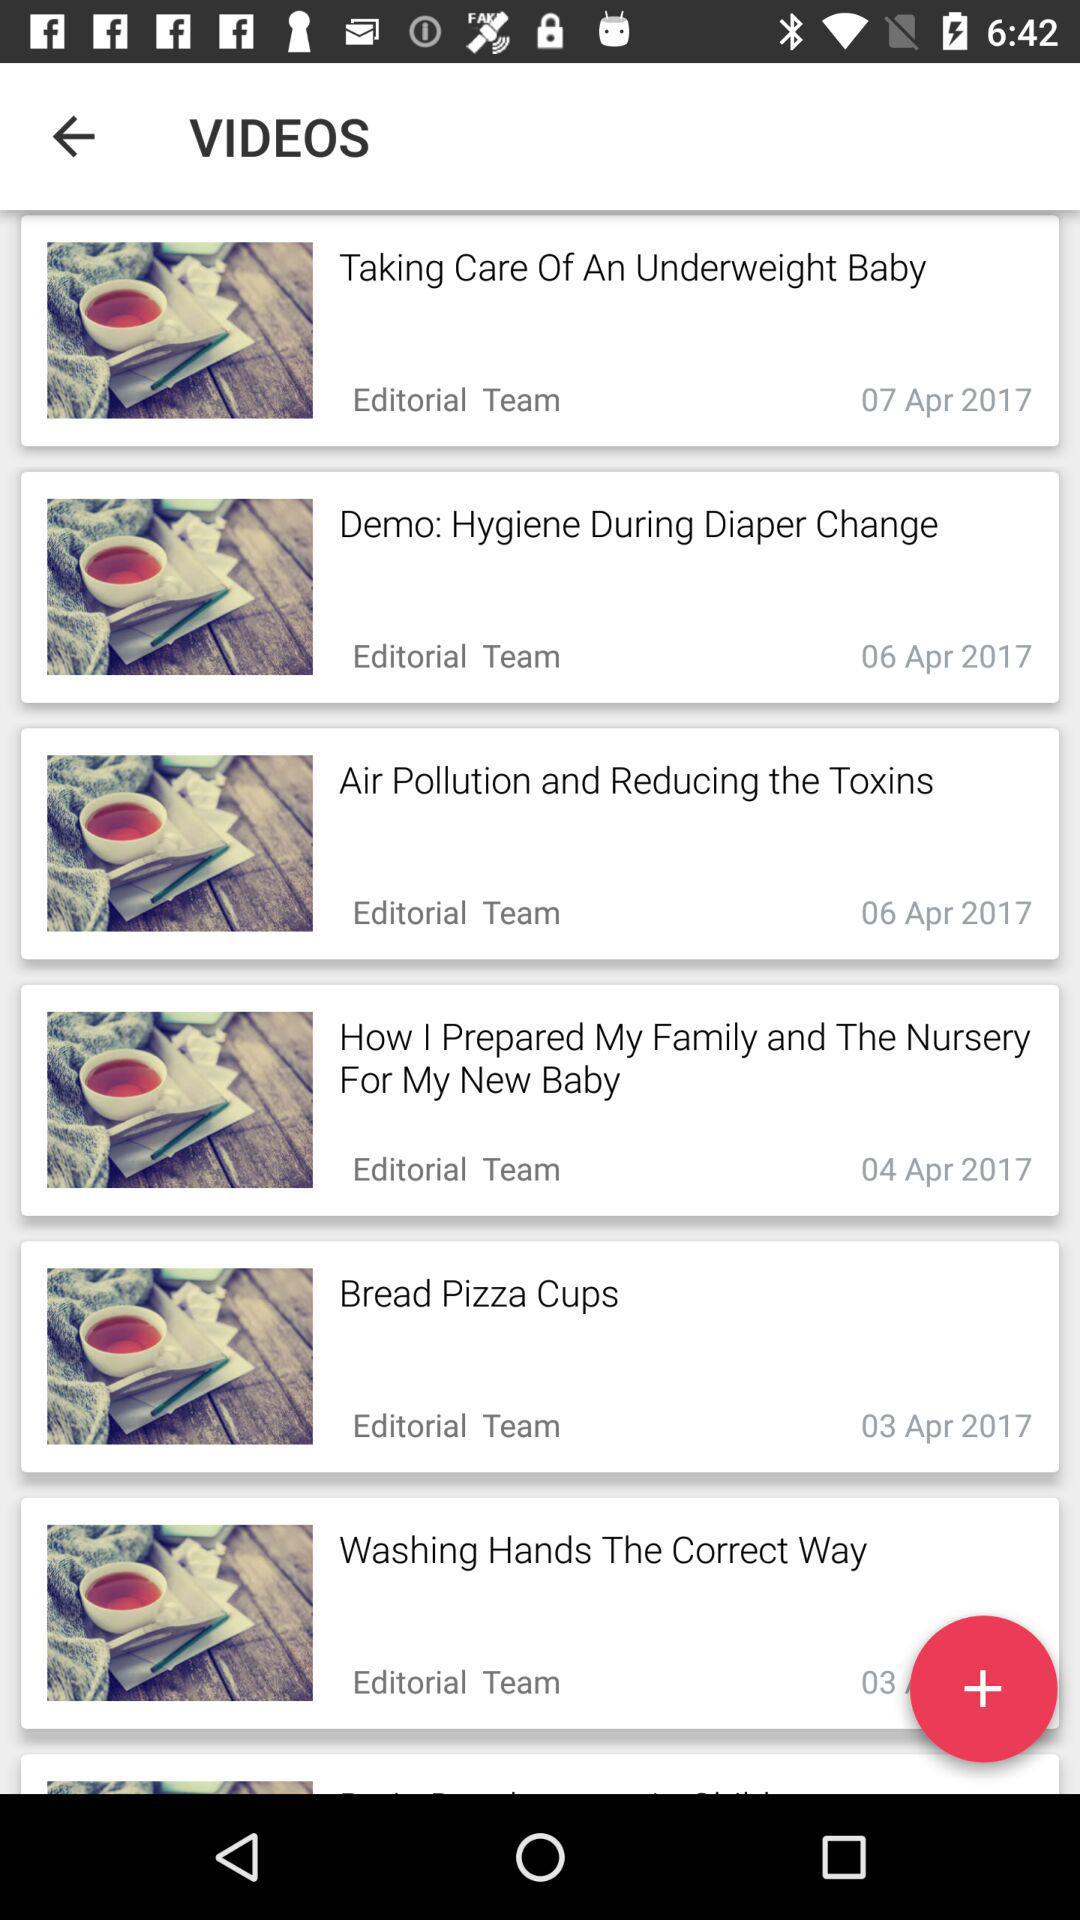When was the video "Demo: Hygiene During Diaper Change" posted? The video was posted on April 5, 2017. 